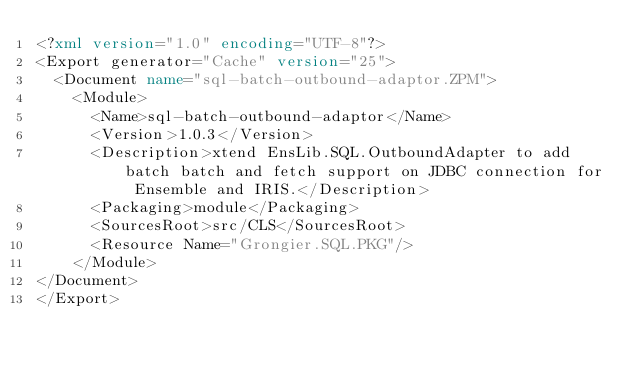<code> <loc_0><loc_0><loc_500><loc_500><_XML_><?xml version="1.0" encoding="UTF-8"?>
<Export generator="Cache" version="25">
  <Document name="sql-batch-outbound-adaptor.ZPM">
    <Module>
      <Name>sql-batch-outbound-adaptor</Name>
      <Version>1.0.3</Version>
      <Description>xtend EnsLib.SQL.OutboundAdapter to add batch batch and fetch support on JDBC connection for Ensemble and IRIS.</Description>
      <Packaging>module</Packaging>
      <SourcesRoot>src/CLS</SourcesRoot>
      <Resource Name="Grongier.SQL.PKG"/>
    </Module>
</Document>
</Export>
</code> 